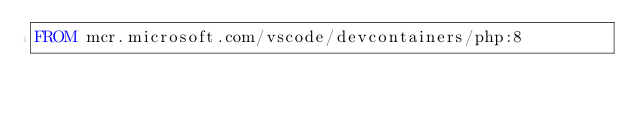<code> <loc_0><loc_0><loc_500><loc_500><_Dockerfile_>FROM mcr.microsoft.com/vscode/devcontainers/php:8
</code> 